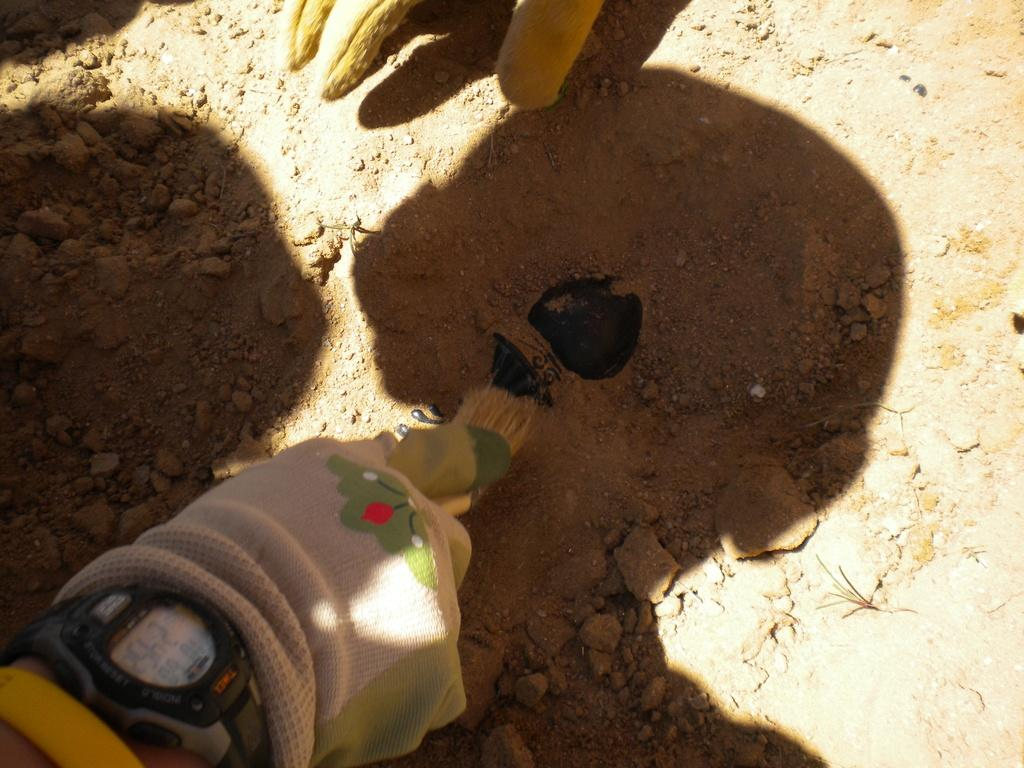What is being held by the hands in the image? The hands are holding a brush in the image. What are the hands wearing? The hands are wearing gloves in the image. Can you identify any accessory on the hands? Yes, there is a watch on one of the hands. What is the texture or substance at the bottom of the image? Mud is present at the bottom of the image. What route is the spoon taking through the image? There is no spoon present in the image, so it cannot be determined what route it might take. 